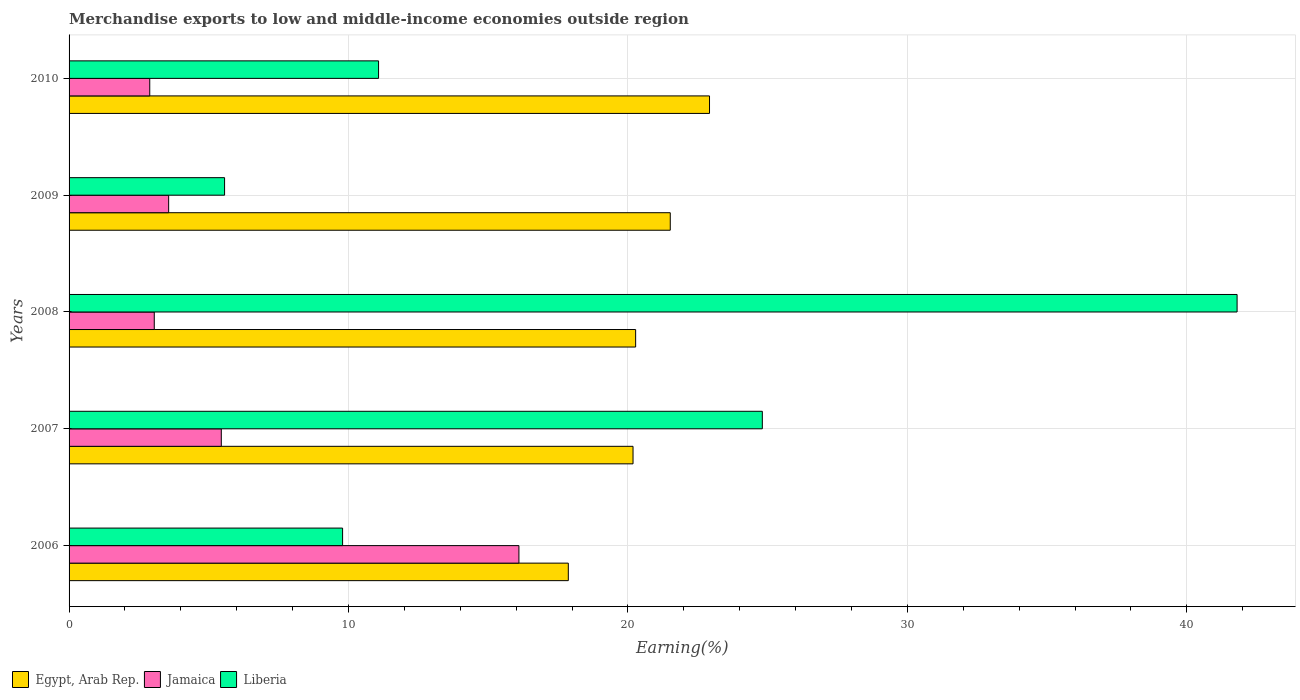How many groups of bars are there?
Your response must be concise. 5. Are the number of bars per tick equal to the number of legend labels?
Provide a short and direct response. Yes. How many bars are there on the 3rd tick from the bottom?
Your answer should be very brief. 3. What is the label of the 2nd group of bars from the top?
Give a very brief answer. 2009. What is the percentage of amount earned from merchandise exports in Egypt, Arab Rep. in 2010?
Give a very brief answer. 22.92. Across all years, what is the maximum percentage of amount earned from merchandise exports in Egypt, Arab Rep.?
Your answer should be very brief. 22.92. Across all years, what is the minimum percentage of amount earned from merchandise exports in Egypt, Arab Rep.?
Offer a very short reply. 17.86. What is the total percentage of amount earned from merchandise exports in Egypt, Arab Rep. in the graph?
Your answer should be very brief. 102.75. What is the difference between the percentage of amount earned from merchandise exports in Liberia in 2008 and that in 2010?
Offer a terse response. 30.72. What is the difference between the percentage of amount earned from merchandise exports in Egypt, Arab Rep. in 2006 and the percentage of amount earned from merchandise exports in Liberia in 2008?
Give a very brief answer. -23.93. What is the average percentage of amount earned from merchandise exports in Jamaica per year?
Provide a short and direct response. 6.21. In the year 2007, what is the difference between the percentage of amount earned from merchandise exports in Egypt, Arab Rep. and percentage of amount earned from merchandise exports in Jamaica?
Keep it short and to the point. 14.73. In how many years, is the percentage of amount earned from merchandise exports in Liberia greater than 38 %?
Your answer should be compact. 1. What is the ratio of the percentage of amount earned from merchandise exports in Egypt, Arab Rep. in 2007 to that in 2009?
Provide a short and direct response. 0.94. Is the percentage of amount earned from merchandise exports in Egypt, Arab Rep. in 2006 less than that in 2010?
Make the answer very short. Yes. What is the difference between the highest and the second highest percentage of amount earned from merchandise exports in Liberia?
Offer a terse response. 16.99. What is the difference between the highest and the lowest percentage of amount earned from merchandise exports in Egypt, Arab Rep.?
Provide a short and direct response. 5.05. What does the 2nd bar from the top in 2009 represents?
Your response must be concise. Jamaica. What does the 2nd bar from the bottom in 2007 represents?
Offer a very short reply. Jamaica. How many bars are there?
Your response must be concise. 15. Are all the bars in the graph horizontal?
Ensure brevity in your answer.  Yes. Does the graph contain any zero values?
Provide a short and direct response. No. How many legend labels are there?
Your answer should be very brief. 3. What is the title of the graph?
Your answer should be compact. Merchandise exports to low and middle-income economies outside region. Does "Brunei Darussalam" appear as one of the legend labels in the graph?
Keep it short and to the point. No. What is the label or title of the X-axis?
Offer a very short reply. Earning(%). What is the label or title of the Y-axis?
Your response must be concise. Years. What is the Earning(%) of Egypt, Arab Rep. in 2006?
Provide a short and direct response. 17.86. What is the Earning(%) in Jamaica in 2006?
Offer a very short reply. 16.1. What is the Earning(%) of Liberia in 2006?
Your response must be concise. 9.79. What is the Earning(%) of Egypt, Arab Rep. in 2007?
Provide a short and direct response. 20.18. What is the Earning(%) of Jamaica in 2007?
Ensure brevity in your answer.  5.45. What is the Earning(%) in Liberia in 2007?
Your answer should be compact. 24.81. What is the Earning(%) in Egypt, Arab Rep. in 2008?
Make the answer very short. 20.27. What is the Earning(%) in Jamaica in 2008?
Your answer should be very brief. 3.05. What is the Earning(%) in Liberia in 2008?
Your answer should be compact. 41.8. What is the Earning(%) of Egypt, Arab Rep. in 2009?
Your answer should be compact. 21.51. What is the Earning(%) in Jamaica in 2009?
Keep it short and to the point. 3.56. What is the Earning(%) in Liberia in 2009?
Your answer should be compact. 5.56. What is the Earning(%) of Egypt, Arab Rep. in 2010?
Ensure brevity in your answer.  22.92. What is the Earning(%) in Jamaica in 2010?
Ensure brevity in your answer.  2.89. What is the Earning(%) in Liberia in 2010?
Give a very brief answer. 11.07. Across all years, what is the maximum Earning(%) in Egypt, Arab Rep.?
Keep it short and to the point. 22.92. Across all years, what is the maximum Earning(%) in Jamaica?
Ensure brevity in your answer.  16.1. Across all years, what is the maximum Earning(%) of Liberia?
Provide a succinct answer. 41.8. Across all years, what is the minimum Earning(%) in Egypt, Arab Rep.?
Provide a succinct answer. 17.86. Across all years, what is the minimum Earning(%) in Jamaica?
Ensure brevity in your answer.  2.89. Across all years, what is the minimum Earning(%) in Liberia?
Your response must be concise. 5.56. What is the total Earning(%) of Egypt, Arab Rep. in the graph?
Keep it short and to the point. 102.75. What is the total Earning(%) in Jamaica in the graph?
Ensure brevity in your answer.  31.04. What is the total Earning(%) of Liberia in the graph?
Your answer should be very brief. 93.03. What is the difference between the Earning(%) in Egypt, Arab Rep. in 2006 and that in 2007?
Your answer should be very brief. -2.32. What is the difference between the Earning(%) of Jamaica in 2006 and that in 2007?
Keep it short and to the point. 10.65. What is the difference between the Earning(%) of Liberia in 2006 and that in 2007?
Offer a very short reply. -15.02. What is the difference between the Earning(%) in Egypt, Arab Rep. in 2006 and that in 2008?
Offer a very short reply. -2.41. What is the difference between the Earning(%) of Jamaica in 2006 and that in 2008?
Give a very brief answer. 13.05. What is the difference between the Earning(%) of Liberia in 2006 and that in 2008?
Ensure brevity in your answer.  -32.01. What is the difference between the Earning(%) of Egypt, Arab Rep. in 2006 and that in 2009?
Ensure brevity in your answer.  -3.65. What is the difference between the Earning(%) of Jamaica in 2006 and that in 2009?
Your answer should be compact. 12.53. What is the difference between the Earning(%) of Liberia in 2006 and that in 2009?
Offer a terse response. 4.22. What is the difference between the Earning(%) of Egypt, Arab Rep. in 2006 and that in 2010?
Offer a very short reply. -5.05. What is the difference between the Earning(%) in Jamaica in 2006 and that in 2010?
Ensure brevity in your answer.  13.21. What is the difference between the Earning(%) of Liberia in 2006 and that in 2010?
Your answer should be very brief. -1.29. What is the difference between the Earning(%) of Egypt, Arab Rep. in 2007 and that in 2008?
Your answer should be compact. -0.09. What is the difference between the Earning(%) of Jamaica in 2007 and that in 2008?
Your answer should be compact. 2.4. What is the difference between the Earning(%) in Liberia in 2007 and that in 2008?
Offer a very short reply. -16.99. What is the difference between the Earning(%) of Egypt, Arab Rep. in 2007 and that in 2009?
Offer a terse response. -1.33. What is the difference between the Earning(%) of Jamaica in 2007 and that in 2009?
Offer a terse response. 1.88. What is the difference between the Earning(%) of Liberia in 2007 and that in 2009?
Your response must be concise. 19.24. What is the difference between the Earning(%) of Egypt, Arab Rep. in 2007 and that in 2010?
Your answer should be very brief. -2.74. What is the difference between the Earning(%) in Jamaica in 2007 and that in 2010?
Keep it short and to the point. 2.56. What is the difference between the Earning(%) of Liberia in 2007 and that in 2010?
Make the answer very short. 13.73. What is the difference between the Earning(%) of Egypt, Arab Rep. in 2008 and that in 2009?
Provide a succinct answer. -1.24. What is the difference between the Earning(%) in Jamaica in 2008 and that in 2009?
Your answer should be compact. -0.52. What is the difference between the Earning(%) of Liberia in 2008 and that in 2009?
Provide a succinct answer. 36.23. What is the difference between the Earning(%) in Egypt, Arab Rep. in 2008 and that in 2010?
Your response must be concise. -2.64. What is the difference between the Earning(%) in Jamaica in 2008 and that in 2010?
Offer a terse response. 0.16. What is the difference between the Earning(%) of Liberia in 2008 and that in 2010?
Your response must be concise. 30.72. What is the difference between the Earning(%) in Egypt, Arab Rep. in 2009 and that in 2010?
Your answer should be compact. -1.4. What is the difference between the Earning(%) in Jamaica in 2009 and that in 2010?
Your answer should be very brief. 0.68. What is the difference between the Earning(%) in Liberia in 2009 and that in 2010?
Keep it short and to the point. -5.51. What is the difference between the Earning(%) in Egypt, Arab Rep. in 2006 and the Earning(%) in Jamaica in 2007?
Your response must be concise. 12.42. What is the difference between the Earning(%) of Egypt, Arab Rep. in 2006 and the Earning(%) of Liberia in 2007?
Provide a short and direct response. -6.94. What is the difference between the Earning(%) of Jamaica in 2006 and the Earning(%) of Liberia in 2007?
Make the answer very short. -8.71. What is the difference between the Earning(%) of Egypt, Arab Rep. in 2006 and the Earning(%) of Jamaica in 2008?
Provide a succinct answer. 14.82. What is the difference between the Earning(%) of Egypt, Arab Rep. in 2006 and the Earning(%) of Liberia in 2008?
Provide a succinct answer. -23.93. What is the difference between the Earning(%) in Jamaica in 2006 and the Earning(%) in Liberia in 2008?
Give a very brief answer. -25.7. What is the difference between the Earning(%) of Egypt, Arab Rep. in 2006 and the Earning(%) of Jamaica in 2009?
Give a very brief answer. 14.3. What is the difference between the Earning(%) in Egypt, Arab Rep. in 2006 and the Earning(%) in Liberia in 2009?
Keep it short and to the point. 12.3. What is the difference between the Earning(%) in Jamaica in 2006 and the Earning(%) in Liberia in 2009?
Ensure brevity in your answer.  10.53. What is the difference between the Earning(%) of Egypt, Arab Rep. in 2006 and the Earning(%) of Jamaica in 2010?
Offer a terse response. 14.98. What is the difference between the Earning(%) of Egypt, Arab Rep. in 2006 and the Earning(%) of Liberia in 2010?
Ensure brevity in your answer.  6.79. What is the difference between the Earning(%) in Jamaica in 2006 and the Earning(%) in Liberia in 2010?
Offer a terse response. 5.02. What is the difference between the Earning(%) in Egypt, Arab Rep. in 2007 and the Earning(%) in Jamaica in 2008?
Provide a short and direct response. 17.13. What is the difference between the Earning(%) in Egypt, Arab Rep. in 2007 and the Earning(%) in Liberia in 2008?
Ensure brevity in your answer.  -21.62. What is the difference between the Earning(%) of Jamaica in 2007 and the Earning(%) of Liberia in 2008?
Your answer should be compact. -36.35. What is the difference between the Earning(%) in Egypt, Arab Rep. in 2007 and the Earning(%) in Jamaica in 2009?
Make the answer very short. 16.62. What is the difference between the Earning(%) in Egypt, Arab Rep. in 2007 and the Earning(%) in Liberia in 2009?
Offer a very short reply. 14.62. What is the difference between the Earning(%) of Jamaica in 2007 and the Earning(%) of Liberia in 2009?
Offer a very short reply. -0.12. What is the difference between the Earning(%) of Egypt, Arab Rep. in 2007 and the Earning(%) of Jamaica in 2010?
Your answer should be very brief. 17.29. What is the difference between the Earning(%) of Egypt, Arab Rep. in 2007 and the Earning(%) of Liberia in 2010?
Ensure brevity in your answer.  9.11. What is the difference between the Earning(%) of Jamaica in 2007 and the Earning(%) of Liberia in 2010?
Your answer should be very brief. -5.63. What is the difference between the Earning(%) in Egypt, Arab Rep. in 2008 and the Earning(%) in Jamaica in 2009?
Offer a terse response. 16.71. What is the difference between the Earning(%) of Egypt, Arab Rep. in 2008 and the Earning(%) of Liberia in 2009?
Provide a succinct answer. 14.71. What is the difference between the Earning(%) of Jamaica in 2008 and the Earning(%) of Liberia in 2009?
Offer a very short reply. -2.52. What is the difference between the Earning(%) of Egypt, Arab Rep. in 2008 and the Earning(%) of Jamaica in 2010?
Keep it short and to the point. 17.39. What is the difference between the Earning(%) in Egypt, Arab Rep. in 2008 and the Earning(%) in Liberia in 2010?
Offer a very short reply. 9.2. What is the difference between the Earning(%) in Jamaica in 2008 and the Earning(%) in Liberia in 2010?
Provide a short and direct response. -8.03. What is the difference between the Earning(%) of Egypt, Arab Rep. in 2009 and the Earning(%) of Jamaica in 2010?
Provide a succinct answer. 18.63. What is the difference between the Earning(%) of Egypt, Arab Rep. in 2009 and the Earning(%) of Liberia in 2010?
Give a very brief answer. 10.44. What is the difference between the Earning(%) in Jamaica in 2009 and the Earning(%) in Liberia in 2010?
Ensure brevity in your answer.  -7.51. What is the average Earning(%) in Egypt, Arab Rep. per year?
Your response must be concise. 20.55. What is the average Earning(%) in Jamaica per year?
Offer a terse response. 6.21. What is the average Earning(%) in Liberia per year?
Offer a terse response. 18.61. In the year 2006, what is the difference between the Earning(%) of Egypt, Arab Rep. and Earning(%) of Jamaica?
Your response must be concise. 1.77. In the year 2006, what is the difference between the Earning(%) in Egypt, Arab Rep. and Earning(%) in Liberia?
Your answer should be compact. 8.08. In the year 2006, what is the difference between the Earning(%) in Jamaica and Earning(%) in Liberia?
Make the answer very short. 6.31. In the year 2007, what is the difference between the Earning(%) of Egypt, Arab Rep. and Earning(%) of Jamaica?
Keep it short and to the point. 14.73. In the year 2007, what is the difference between the Earning(%) in Egypt, Arab Rep. and Earning(%) in Liberia?
Provide a succinct answer. -4.63. In the year 2007, what is the difference between the Earning(%) of Jamaica and Earning(%) of Liberia?
Keep it short and to the point. -19.36. In the year 2008, what is the difference between the Earning(%) in Egypt, Arab Rep. and Earning(%) in Jamaica?
Keep it short and to the point. 17.23. In the year 2008, what is the difference between the Earning(%) of Egypt, Arab Rep. and Earning(%) of Liberia?
Provide a short and direct response. -21.52. In the year 2008, what is the difference between the Earning(%) of Jamaica and Earning(%) of Liberia?
Your response must be concise. -38.75. In the year 2009, what is the difference between the Earning(%) in Egypt, Arab Rep. and Earning(%) in Jamaica?
Ensure brevity in your answer.  17.95. In the year 2009, what is the difference between the Earning(%) in Egypt, Arab Rep. and Earning(%) in Liberia?
Provide a succinct answer. 15.95. In the year 2009, what is the difference between the Earning(%) in Jamaica and Earning(%) in Liberia?
Keep it short and to the point. -2. In the year 2010, what is the difference between the Earning(%) of Egypt, Arab Rep. and Earning(%) of Jamaica?
Offer a terse response. 20.03. In the year 2010, what is the difference between the Earning(%) of Egypt, Arab Rep. and Earning(%) of Liberia?
Ensure brevity in your answer.  11.84. In the year 2010, what is the difference between the Earning(%) in Jamaica and Earning(%) in Liberia?
Offer a very short reply. -8.19. What is the ratio of the Earning(%) of Egypt, Arab Rep. in 2006 to that in 2007?
Offer a terse response. 0.89. What is the ratio of the Earning(%) of Jamaica in 2006 to that in 2007?
Make the answer very short. 2.96. What is the ratio of the Earning(%) of Liberia in 2006 to that in 2007?
Give a very brief answer. 0.39. What is the ratio of the Earning(%) in Egypt, Arab Rep. in 2006 to that in 2008?
Provide a short and direct response. 0.88. What is the ratio of the Earning(%) of Jamaica in 2006 to that in 2008?
Ensure brevity in your answer.  5.28. What is the ratio of the Earning(%) of Liberia in 2006 to that in 2008?
Keep it short and to the point. 0.23. What is the ratio of the Earning(%) of Egypt, Arab Rep. in 2006 to that in 2009?
Give a very brief answer. 0.83. What is the ratio of the Earning(%) in Jamaica in 2006 to that in 2009?
Provide a succinct answer. 4.52. What is the ratio of the Earning(%) in Liberia in 2006 to that in 2009?
Provide a short and direct response. 1.76. What is the ratio of the Earning(%) of Egypt, Arab Rep. in 2006 to that in 2010?
Offer a very short reply. 0.78. What is the ratio of the Earning(%) of Jamaica in 2006 to that in 2010?
Your answer should be very brief. 5.58. What is the ratio of the Earning(%) in Liberia in 2006 to that in 2010?
Keep it short and to the point. 0.88. What is the ratio of the Earning(%) of Jamaica in 2007 to that in 2008?
Your answer should be compact. 1.79. What is the ratio of the Earning(%) of Liberia in 2007 to that in 2008?
Ensure brevity in your answer.  0.59. What is the ratio of the Earning(%) of Egypt, Arab Rep. in 2007 to that in 2009?
Make the answer very short. 0.94. What is the ratio of the Earning(%) of Jamaica in 2007 to that in 2009?
Your answer should be very brief. 1.53. What is the ratio of the Earning(%) of Liberia in 2007 to that in 2009?
Ensure brevity in your answer.  4.46. What is the ratio of the Earning(%) in Egypt, Arab Rep. in 2007 to that in 2010?
Provide a short and direct response. 0.88. What is the ratio of the Earning(%) in Jamaica in 2007 to that in 2010?
Offer a very short reply. 1.89. What is the ratio of the Earning(%) in Liberia in 2007 to that in 2010?
Make the answer very short. 2.24. What is the ratio of the Earning(%) of Egypt, Arab Rep. in 2008 to that in 2009?
Offer a terse response. 0.94. What is the ratio of the Earning(%) in Jamaica in 2008 to that in 2009?
Offer a very short reply. 0.86. What is the ratio of the Earning(%) of Liberia in 2008 to that in 2009?
Offer a very short reply. 7.51. What is the ratio of the Earning(%) of Egypt, Arab Rep. in 2008 to that in 2010?
Provide a short and direct response. 0.88. What is the ratio of the Earning(%) of Jamaica in 2008 to that in 2010?
Your answer should be very brief. 1.06. What is the ratio of the Earning(%) of Liberia in 2008 to that in 2010?
Provide a succinct answer. 3.77. What is the ratio of the Earning(%) in Egypt, Arab Rep. in 2009 to that in 2010?
Provide a succinct answer. 0.94. What is the ratio of the Earning(%) of Jamaica in 2009 to that in 2010?
Make the answer very short. 1.23. What is the ratio of the Earning(%) in Liberia in 2009 to that in 2010?
Your answer should be very brief. 0.5. What is the difference between the highest and the second highest Earning(%) in Egypt, Arab Rep.?
Your answer should be compact. 1.4. What is the difference between the highest and the second highest Earning(%) of Jamaica?
Provide a succinct answer. 10.65. What is the difference between the highest and the second highest Earning(%) in Liberia?
Offer a terse response. 16.99. What is the difference between the highest and the lowest Earning(%) in Egypt, Arab Rep.?
Offer a very short reply. 5.05. What is the difference between the highest and the lowest Earning(%) of Jamaica?
Provide a short and direct response. 13.21. What is the difference between the highest and the lowest Earning(%) in Liberia?
Offer a terse response. 36.23. 